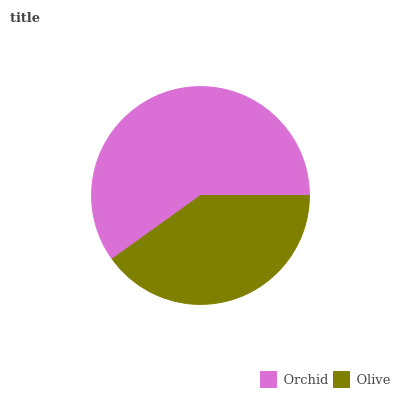Is Olive the minimum?
Answer yes or no. Yes. Is Orchid the maximum?
Answer yes or no. Yes. Is Olive the maximum?
Answer yes or no. No. Is Orchid greater than Olive?
Answer yes or no. Yes. Is Olive less than Orchid?
Answer yes or no. Yes. Is Olive greater than Orchid?
Answer yes or no. No. Is Orchid less than Olive?
Answer yes or no. No. Is Orchid the high median?
Answer yes or no. Yes. Is Olive the low median?
Answer yes or no. Yes. Is Olive the high median?
Answer yes or no. No. Is Orchid the low median?
Answer yes or no. No. 